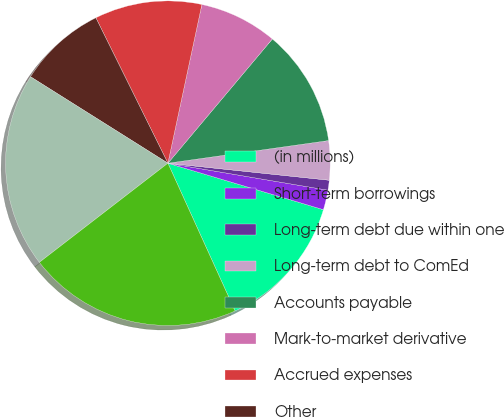Convert chart. <chart><loc_0><loc_0><loc_500><loc_500><pie_chart><fcel>(in millions)<fcel>Short-term borrowings<fcel>Long-term debt due within one<fcel>Long-term debt to ComEd<fcel>Accounts payable<fcel>Mark-to-market derivative<fcel>Accrued expenses<fcel>Other<fcel>Total current liabilities<fcel>Long-term debt<nl><fcel>13.59%<fcel>1.96%<fcel>0.99%<fcel>3.9%<fcel>11.65%<fcel>7.77%<fcel>10.68%<fcel>8.74%<fcel>19.4%<fcel>21.34%<nl></chart> 